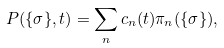<formula> <loc_0><loc_0><loc_500><loc_500>P ( \{ \sigma \} , t ) = \sum _ { n } c _ { n } ( t ) \pi _ { n } ( \{ \sigma \} ) ,</formula> 